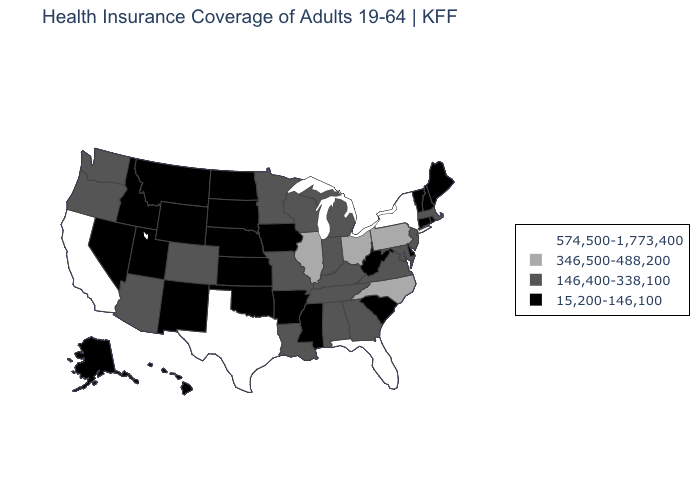Name the states that have a value in the range 346,500-488,200?
Be succinct. Illinois, North Carolina, Ohio, Pennsylvania. What is the value of Missouri?
Keep it brief. 146,400-338,100. What is the value of Iowa?
Write a very short answer. 15,200-146,100. What is the highest value in the Northeast ?
Concise answer only. 574,500-1,773,400. Does Alabama have the lowest value in the USA?
Be succinct. No. Which states have the lowest value in the USA?
Quick response, please. Alaska, Arkansas, Connecticut, Delaware, Hawaii, Idaho, Iowa, Kansas, Maine, Mississippi, Montana, Nebraska, Nevada, New Hampshire, New Mexico, North Dakota, Oklahoma, Rhode Island, South Carolina, South Dakota, Utah, Vermont, West Virginia, Wyoming. Name the states that have a value in the range 346,500-488,200?
Give a very brief answer. Illinois, North Carolina, Ohio, Pennsylvania. What is the value of Iowa?
Be succinct. 15,200-146,100. Does Virginia have the same value as Maine?
Keep it brief. No. Does Florida have the highest value in the South?
Write a very short answer. Yes. What is the value of Maine?
Keep it brief. 15,200-146,100. What is the value of Illinois?
Give a very brief answer. 346,500-488,200. Which states have the lowest value in the USA?
Write a very short answer. Alaska, Arkansas, Connecticut, Delaware, Hawaii, Idaho, Iowa, Kansas, Maine, Mississippi, Montana, Nebraska, Nevada, New Hampshire, New Mexico, North Dakota, Oklahoma, Rhode Island, South Carolina, South Dakota, Utah, Vermont, West Virginia, Wyoming. Among the states that border South Dakota , does Minnesota have the highest value?
Quick response, please. Yes. Name the states that have a value in the range 15,200-146,100?
Write a very short answer. Alaska, Arkansas, Connecticut, Delaware, Hawaii, Idaho, Iowa, Kansas, Maine, Mississippi, Montana, Nebraska, Nevada, New Hampshire, New Mexico, North Dakota, Oklahoma, Rhode Island, South Carolina, South Dakota, Utah, Vermont, West Virginia, Wyoming. 